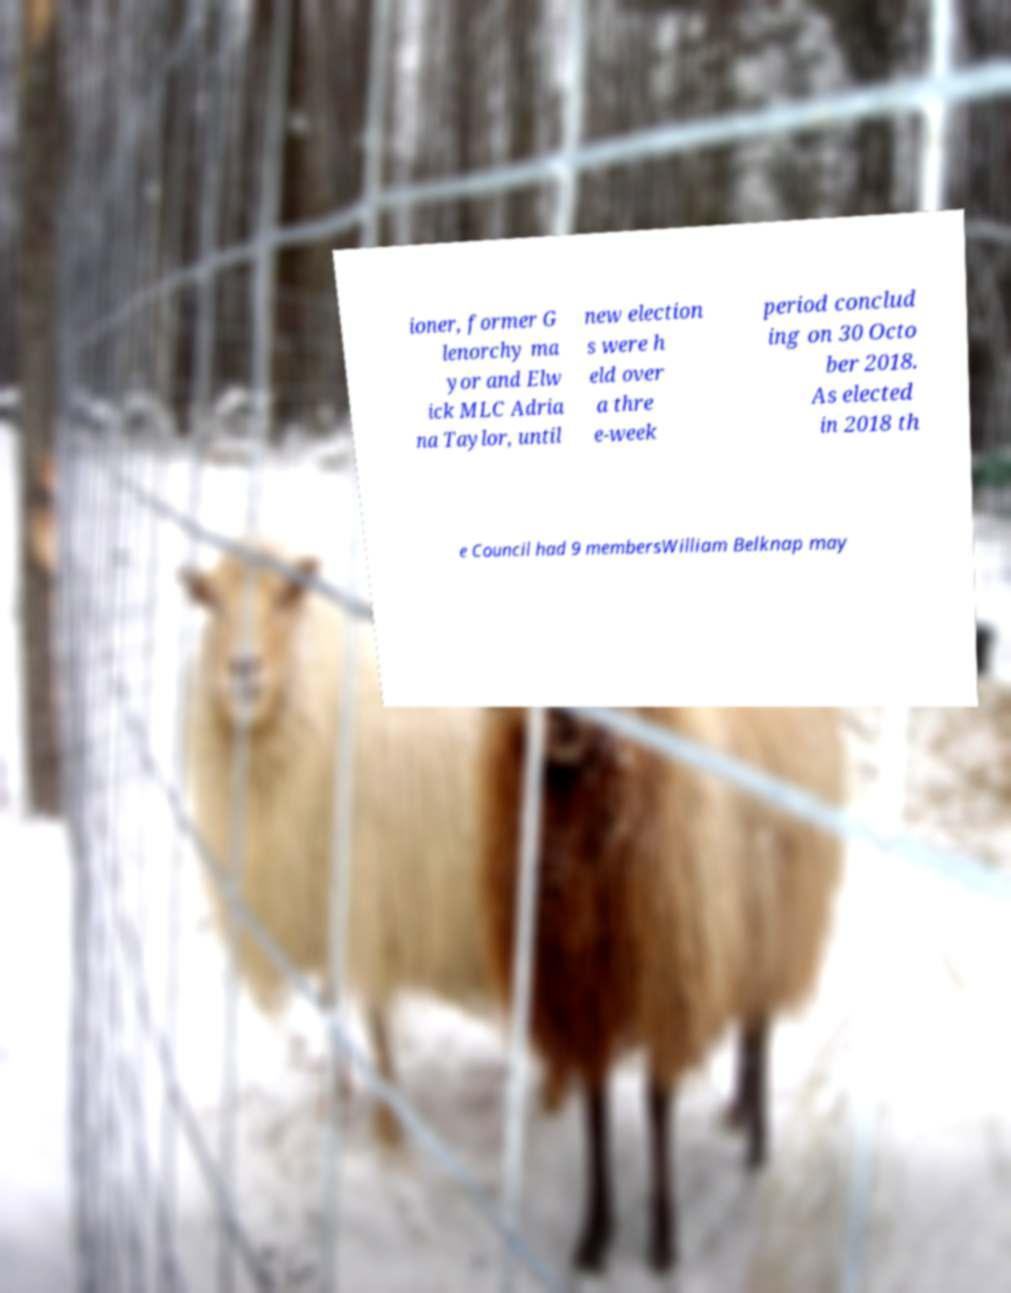Please read and relay the text visible in this image. What does it say? ioner, former G lenorchy ma yor and Elw ick MLC Adria na Taylor, until new election s were h eld over a thre e-week period conclud ing on 30 Octo ber 2018. As elected in 2018 th e Council had 9 membersWilliam Belknap may 